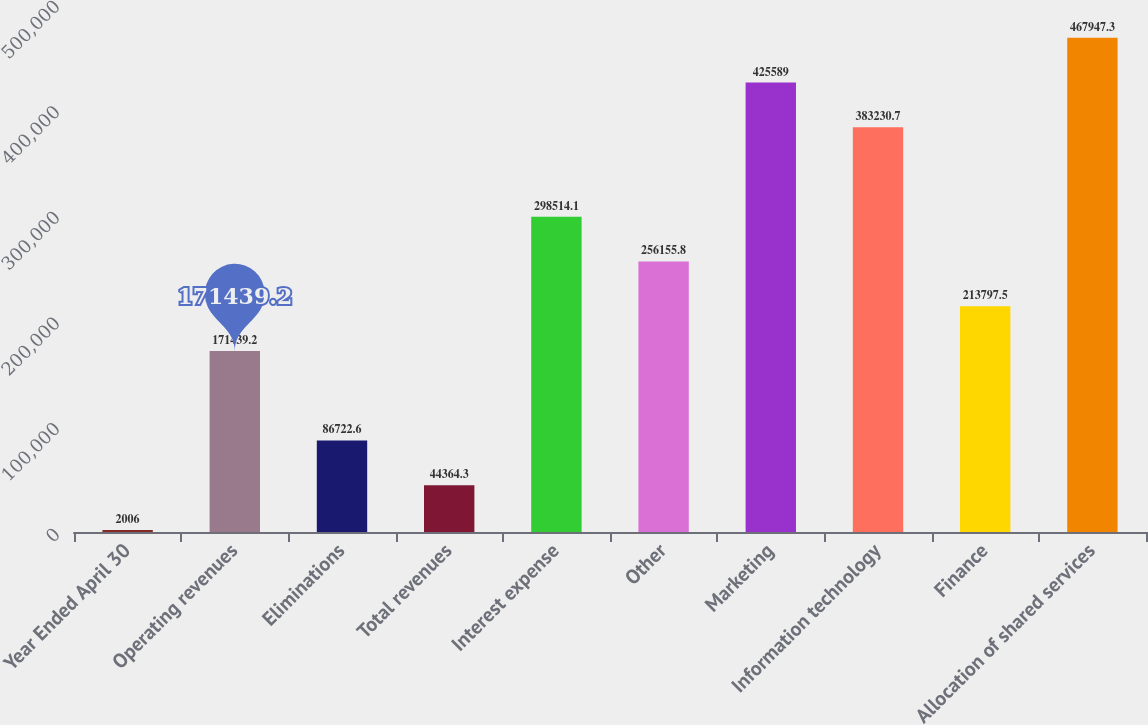Convert chart. <chart><loc_0><loc_0><loc_500><loc_500><bar_chart><fcel>Year Ended April 30<fcel>Operating revenues<fcel>Eliminations<fcel>Total revenues<fcel>Interest expense<fcel>Other<fcel>Marketing<fcel>Information technology<fcel>Finance<fcel>Allocation of shared services<nl><fcel>2006<fcel>171439<fcel>86722.6<fcel>44364.3<fcel>298514<fcel>256156<fcel>425589<fcel>383231<fcel>213798<fcel>467947<nl></chart> 